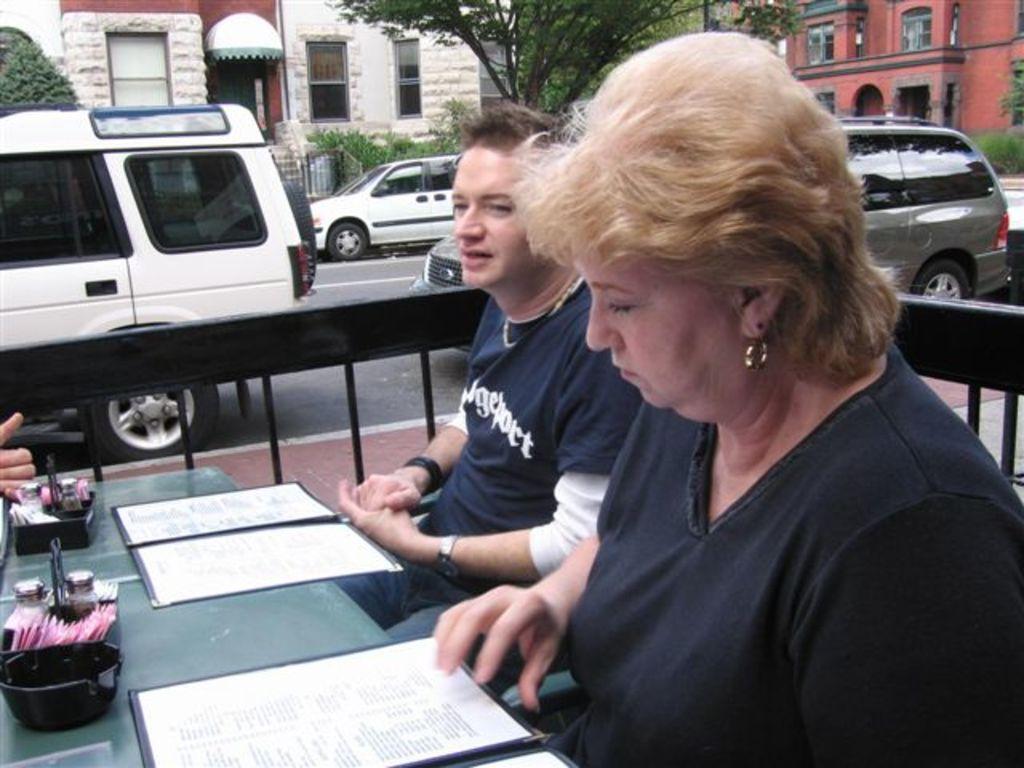In one or two sentences, can you explain what this image depicts? In this picture we can see two people are sitting on chairs. In front of them we can see the table with menu covers, bowls, jars and some objects on it. In the background we can see vehicles on the road, fence, trees and buildings with windows. 